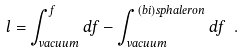<formula> <loc_0><loc_0><loc_500><loc_500>l = \int _ { v a c u u m } ^ { f } d f - \int _ { v a c u u m } ^ { ( b i ) s p h a l e r o n } d f \ .</formula> 